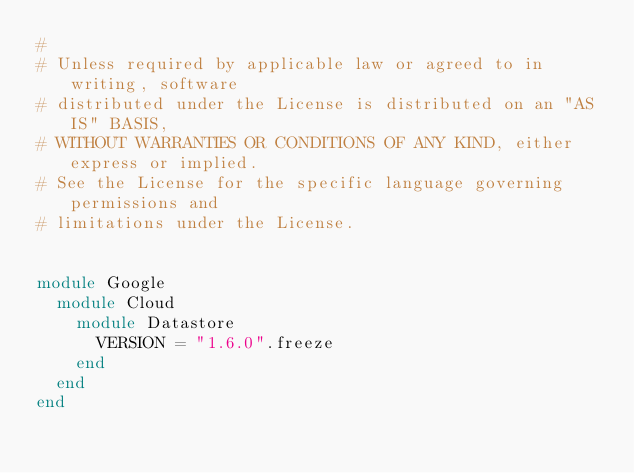Convert code to text. <code><loc_0><loc_0><loc_500><loc_500><_Ruby_>#
# Unless required by applicable law or agreed to in writing, software
# distributed under the License is distributed on an "AS IS" BASIS,
# WITHOUT WARRANTIES OR CONDITIONS OF ANY KIND, either express or implied.
# See the License for the specific language governing permissions and
# limitations under the License.


module Google
  module Cloud
    module Datastore
      VERSION = "1.6.0".freeze
    end
  end
end
</code> 